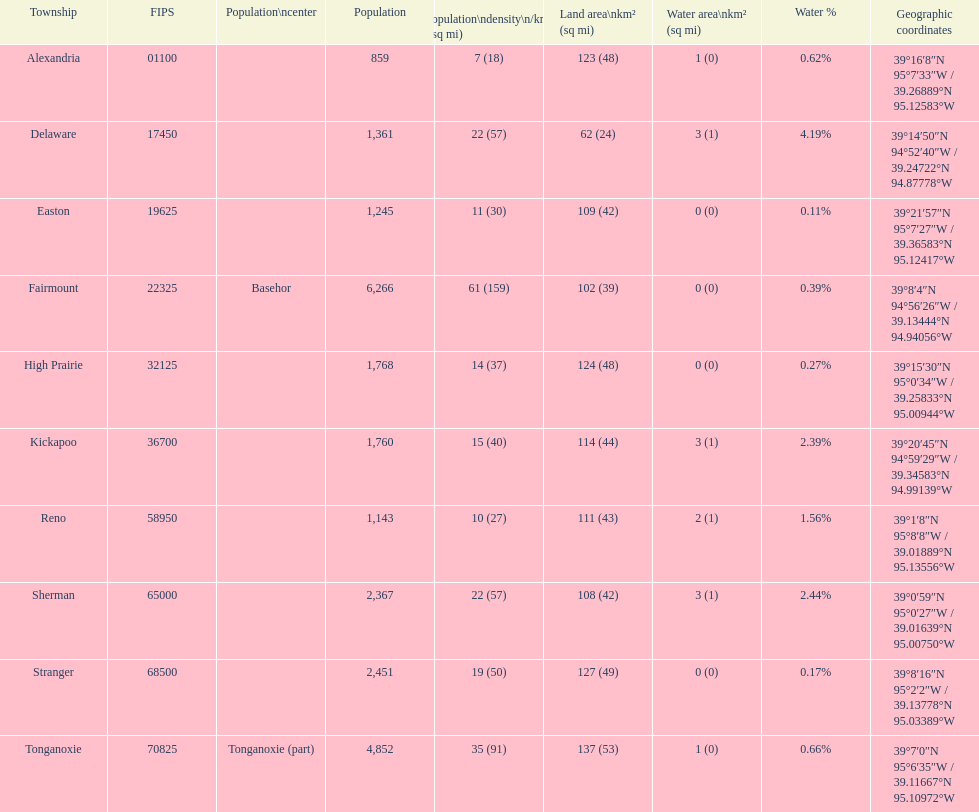Can you compare the population sizes of alexandria county and delaware county? Lower. 